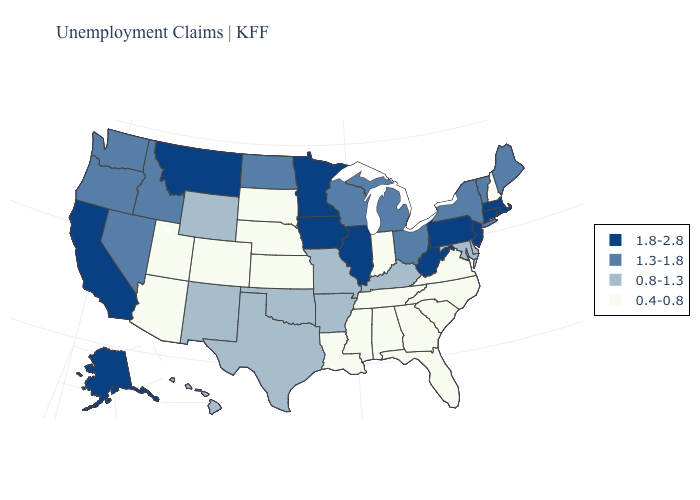What is the lowest value in the MidWest?
Be succinct. 0.4-0.8. Name the states that have a value in the range 0.8-1.3?
Concise answer only. Arkansas, Delaware, Hawaii, Kentucky, Maryland, Missouri, New Mexico, Oklahoma, Texas, Wyoming. Among the states that border Wisconsin , does Michigan have the highest value?
Answer briefly. No. What is the value of North Dakota?
Answer briefly. 1.3-1.8. Does the map have missing data?
Keep it brief. No. Does Pennsylvania have the highest value in the USA?
Quick response, please. Yes. Does Minnesota have a higher value than Oregon?
Be succinct. Yes. What is the value of Washington?
Write a very short answer. 1.3-1.8. What is the value of Mississippi?
Answer briefly. 0.4-0.8. Does Rhode Island have the lowest value in the Northeast?
Keep it brief. No. What is the value of West Virginia?
Quick response, please. 1.8-2.8. Does North Dakota have a higher value than Maryland?
Quick response, please. Yes. What is the highest value in the USA?
Quick response, please. 1.8-2.8. What is the value of Arizona?
Write a very short answer. 0.4-0.8. Does Massachusetts have the same value as South Carolina?
Write a very short answer. No. 